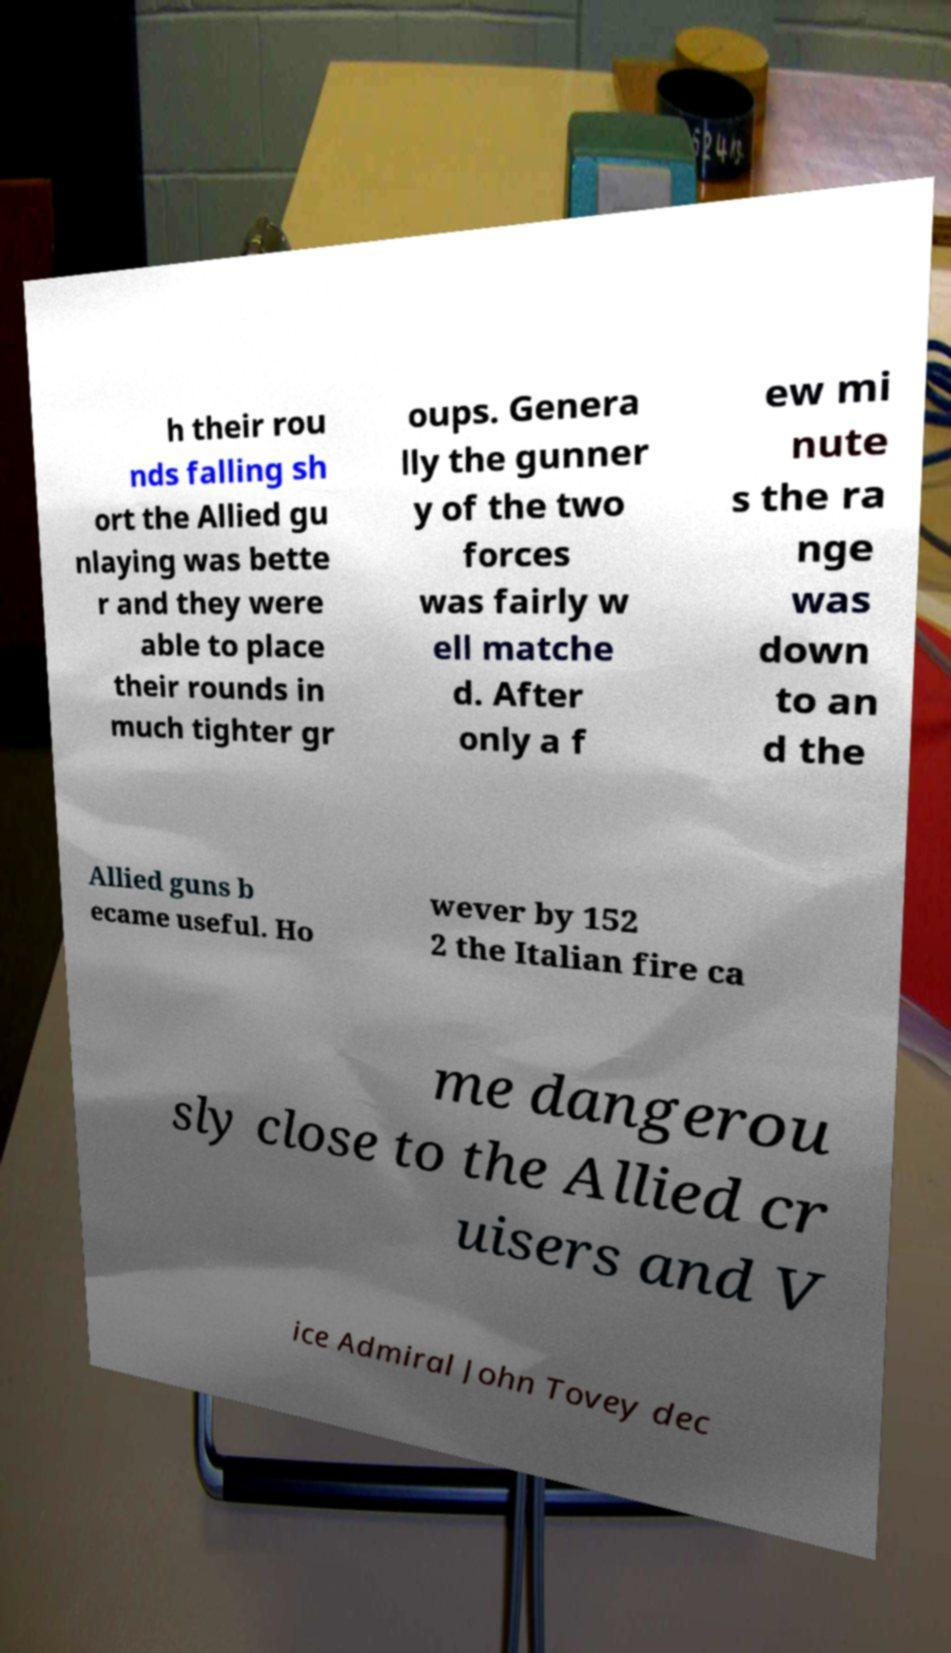What messages or text are displayed in this image? I need them in a readable, typed format. h their rou nds falling sh ort the Allied gu nlaying was bette r and they were able to place their rounds in much tighter gr oups. Genera lly the gunner y of the two forces was fairly w ell matche d. After only a f ew mi nute s the ra nge was down to an d the Allied guns b ecame useful. Ho wever by 152 2 the Italian fire ca me dangerou sly close to the Allied cr uisers and V ice Admiral John Tovey dec 